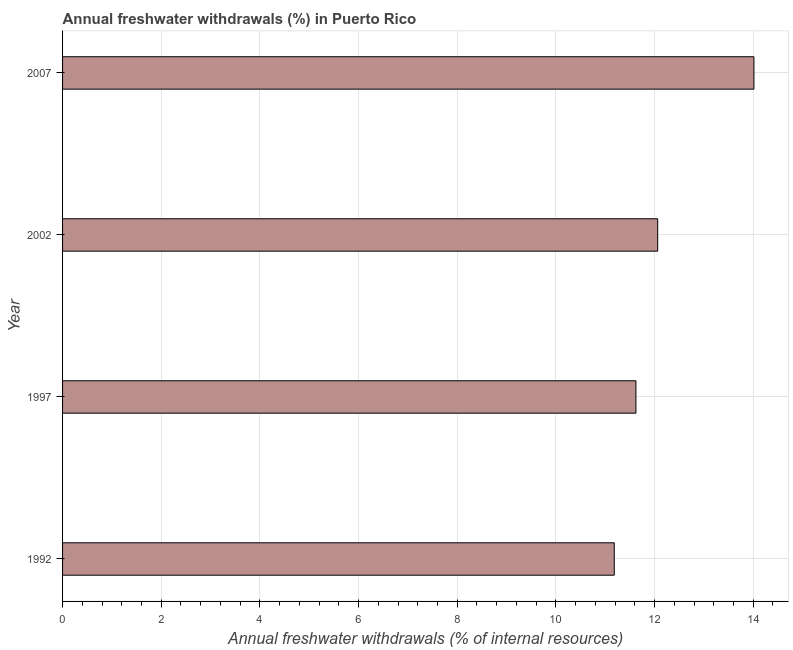Does the graph contain any zero values?
Provide a succinct answer. No. What is the title of the graph?
Keep it short and to the point. Annual freshwater withdrawals (%) in Puerto Rico. What is the label or title of the X-axis?
Provide a short and direct response. Annual freshwater withdrawals (% of internal resources). What is the annual freshwater withdrawals in 2007?
Keep it short and to the point. 14.01. Across all years, what is the maximum annual freshwater withdrawals?
Provide a short and direct response. 14.01. Across all years, what is the minimum annual freshwater withdrawals?
Provide a short and direct response. 11.18. In which year was the annual freshwater withdrawals minimum?
Your answer should be very brief. 1992. What is the sum of the annual freshwater withdrawals?
Offer a terse response. 48.88. What is the difference between the annual freshwater withdrawals in 2002 and 2007?
Ensure brevity in your answer.  -1.95. What is the average annual freshwater withdrawals per year?
Provide a short and direct response. 12.22. What is the median annual freshwater withdrawals?
Your answer should be compact. 11.84. What is the ratio of the annual freshwater withdrawals in 2002 to that in 2007?
Your answer should be very brief. 0.86. Is the annual freshwater withdrawals in 2002 less than that in 2007?
Offer a terse response. Yes. What is the difference between the highest and the second highest annual freshwater withdrawals?
Offer a very short reply. 1.95. Is the sum of the annual freshwater withdrawals in 1997 and 2002 greater than the maximum annual freshwater withdrawals across all years?
Provide a succinct answer. Yes. What is the difference between the highest and the lowest annual freshwater withdrawals?
Provide a short and direct response. 2.83. In how many years, is the annual freshwater withdrawals greater than the average annual freshwater withdrawals taken over all years?
Your response must be concise. 1. How many bars are there?
Your answer should be very brief. 4. What is the difference between two consecutive major ticks on the X-axis?
Give a very brief answer. 2. What is the Annual freshwater withdrawals (% of internal resources) of 1992?
Provide a succinct answer. 11.18. What is the Annual freshwater withdrawals (% of internal resources) of 1997?
Keep it short and to the point. 11.62. What is the Annual freshwater withdrawals (% of internal resources) in 2002?
Ensure brevity in your answer.  12.06. What is the Annual freshwater withdrawals (% of internal resources) of 2007?
Give a very brief answer. 14.01. What is the difference between the Annual freshwater withdrawals (% of internal resources) in 1992 and 1997?
Provide a succinct answer. -0.44. What is the difference between the Annual freshwater withdrawals (% of internal resources) in 1992 and 2002?
Offer a terse response. -0.88. What is the difference between the Annual freshwater withdrawals (% of internal resources) in 1992 and 2007?
Your answer should be compact. -2.83. What is the difference between the Annual freshwater withdrawals (% of internal resources) in 1997 and 2002?
Provide a succinct answer. -0.44. What is the difference between the Annual freshwater withdrawals (% of internal resources) in 1997 and 2007?
Offer a terse response. -2.39. What is the difference between the Annual freshwater withdrawals (% of internal resources) in 2002 and 2007?
Give a very brief answer. -1.95. What is the ratio of the Annual freshwater withdrawals (% of internal resources) in 1992 to that in 1997?
Your response must be concise. 0.96. What is the ratio of the Annual freshwater withdrawals (% of internal resources) in 1992 to that in 2002?
Ensure brevity in your answer.  0.93. What is the ratio of the Annual freshwater withdrawals (% of internal resources) in 1992 to that in 2007?
Your answer should be very brief. 0.8. What is the ratio of the Annual freshwater withdrawals (% of internal resources) in 1997 to that in 2007?
Ensure brevity in your answer.  0.83. What is the ratio of the Annual freshwater withdrawals (% of internal resources) in 2002 to that in 2007?
Keep it short and to the point. 0.86. 